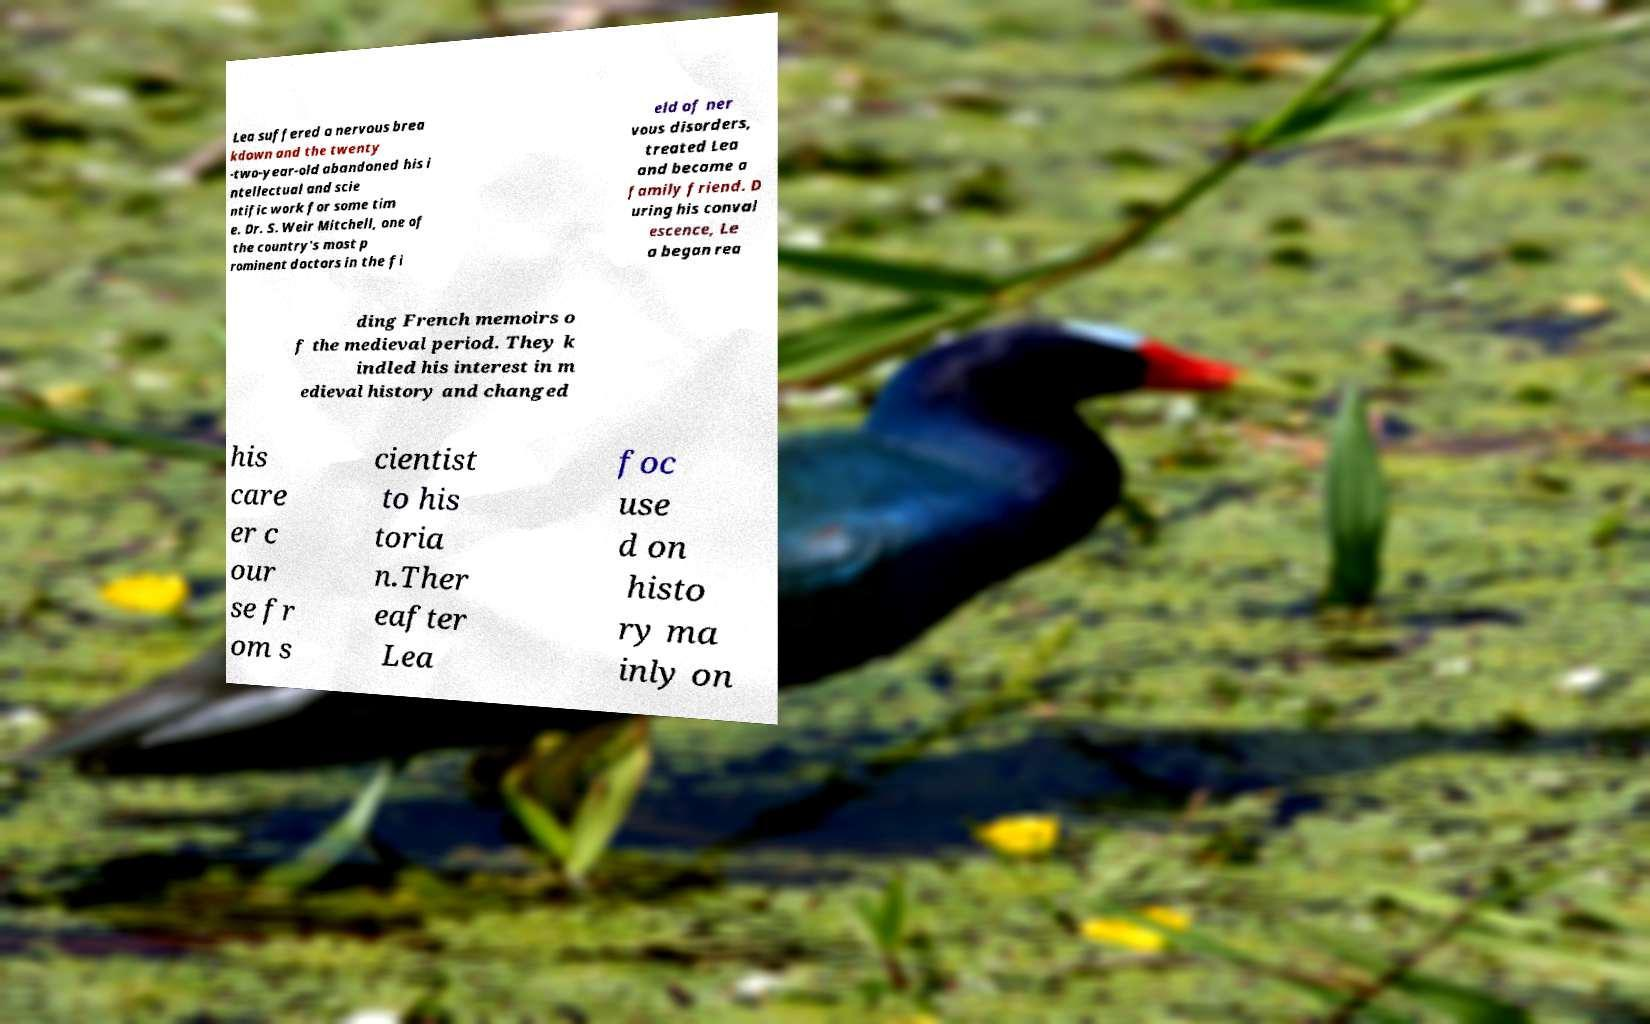There's text embedded in this image that I need extracted. Can you transcribe it verbatim? Lea suffered a nervous brea kdown and the twenty -two-year-old abandoned his i ntellectual and scie ntific work for some tim e. Dr. S. Weir Mitchell, one of the country's most p rominent doctors in the fi eld of ner vous disorders, treated Lea and became a family friend. D uring his conval escence, Le a began rea ding French memoirs o f the medieval period. They k indled his interest in m edieval history and changed his care er c our se fr om s cientist to his toria n.Ther eafter Lea foc use d on histo ry ma inly on 